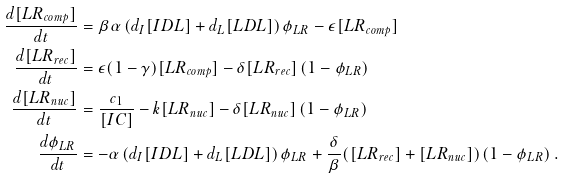<formula> <loc_0><loc_0><loc_500><loc_500>\frac { d [ L R _ { c o m p } ] } { d t } & = \beta \alpha \left ( d _ { I } [ I D L ] + d _ { L } [ L D L ] \right ) \phi _ { L R } - \epsilon [ L R _ { c o m p } ] \\ \frac { d [ L R _ { r e c } ] } { d t } & = \epsilon ( 1 - \gamma ) [ L R _ { c o m p } ] - \delta [ L R _ { r e c } ] \left ( 1 - \phi _ { L R } \right ) \\ \frac { d [ L R _ { n u c } ] } { d t } & = \frac { c _ { 1 } } { [ I C ] } - k [ L R _ { n u c } ] - \delta [ L R _ { n u c } ] \left ( 1 - \phi _ { L R } \right ) \\ \frac { d \phi _ { L R } } { d t } & = - \alpha \left ( d _ { I } [ I D L ] + d _ { L } [ L D L ] \right ) \phi _ { L R } + \frac { \delta } { \beta } ( [ L R _ { r e c } ] + [ L R _ { n u c } ] ) \left ( 1 - \phi _ { L R } \right ) .</formula> 